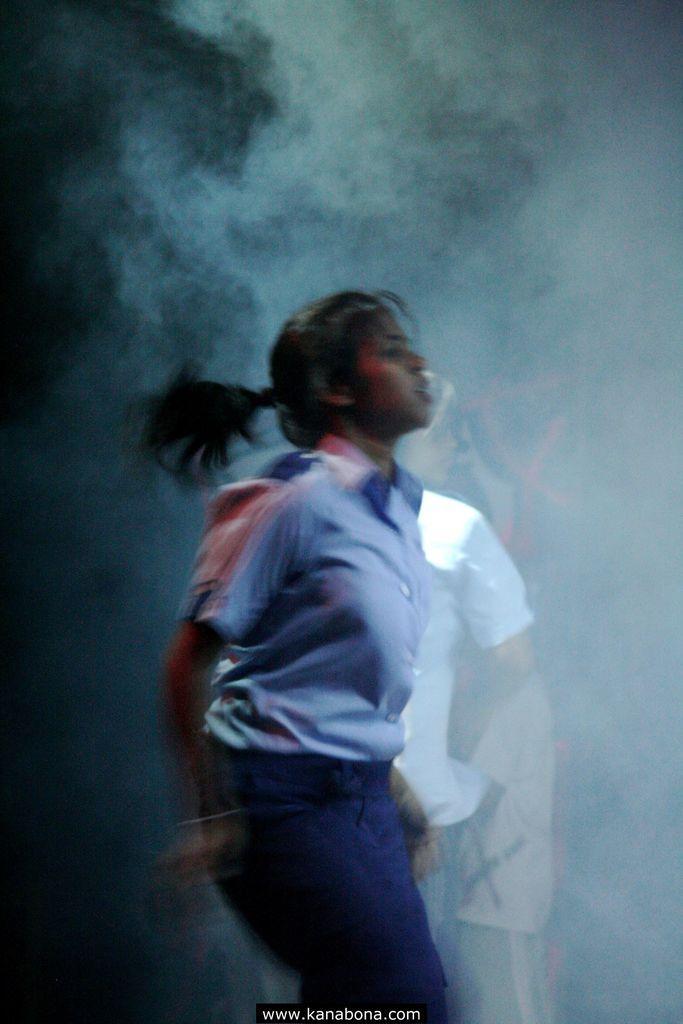How would you summarize this image in a sentence or two? In this image there is a woman in uniform and there is a website address on the image. In the background there are few more people and there is smoke. 